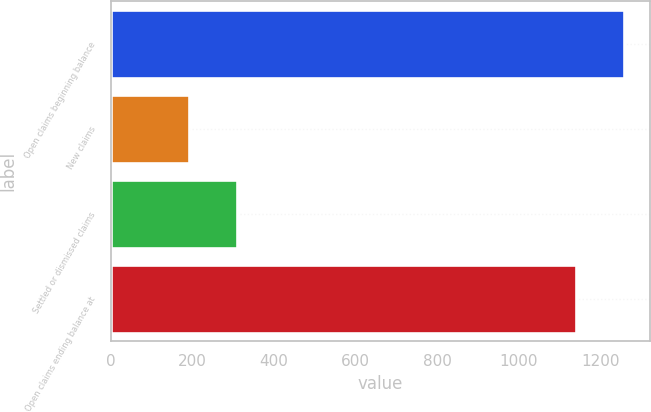Convert chart to OTSL. <chart><loc_0><loc_0><loc_500><loc_500><bar_chart><fcel>Open claims beginning balance<fcel>New claims<fcel>Settled or dismissed claims<fcel>Open claims ending balance at<nl><fcel>1258<fcel>192<fcel>310<fcel>1140<nl></chart> 